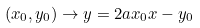Convert formula to latex. <formula><loc_0><loc_0><loc_500><loc_500>( x _ { 0 } , y _ { 0 } ) \to y = 2 a x _ { 0 } x - y _ { 0 }</formula> 